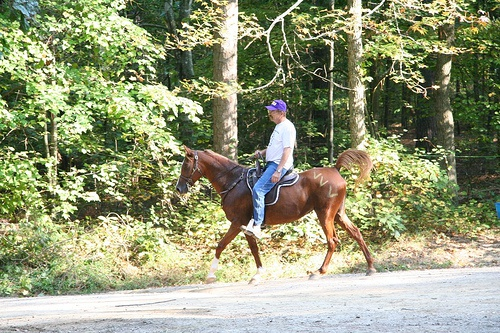Describe the objects in this image and their specific colors. I can see horse in black, maroon, and gray tones and people in black, lavender, lightblue, and gray tones in this image. 